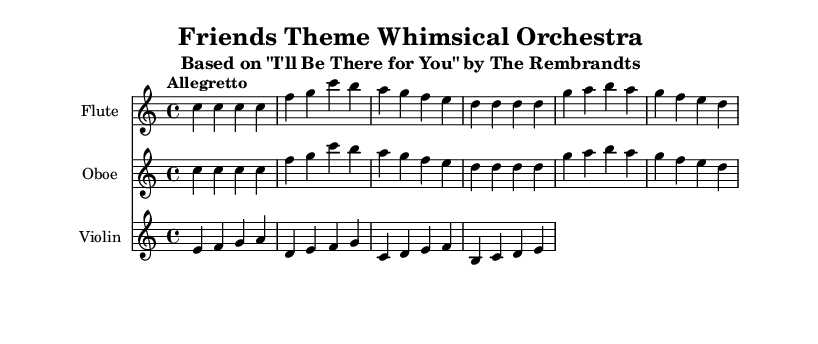What is the key signature of this music? The key signature is C major, which has no sharps or flats.
Answer: C major What is the time signature of this piece? The time signature is indicated at the beginning of the score as 4/4, meaning there are four beats in a measure.
Answer: 4/4 What is the tempo marking for this arrangement? The tempo marking is "Allegretto," suggesting a moderately fast pace.
Answer: Allegretto How many measures are in the flute part? By counting the measures presented in the flute staff, there are a total of four measures.
Answer: 4 How do the melodies of the flute and oboe compare? The melodies of the flute and oboe are identical, showing that they play the same notes throughout their respective parts.
Answer: Identical What is the highest note played by the violin in this piece? The highest note played by the violin is E, found in the last measure of the violin staff.
Answer: E 